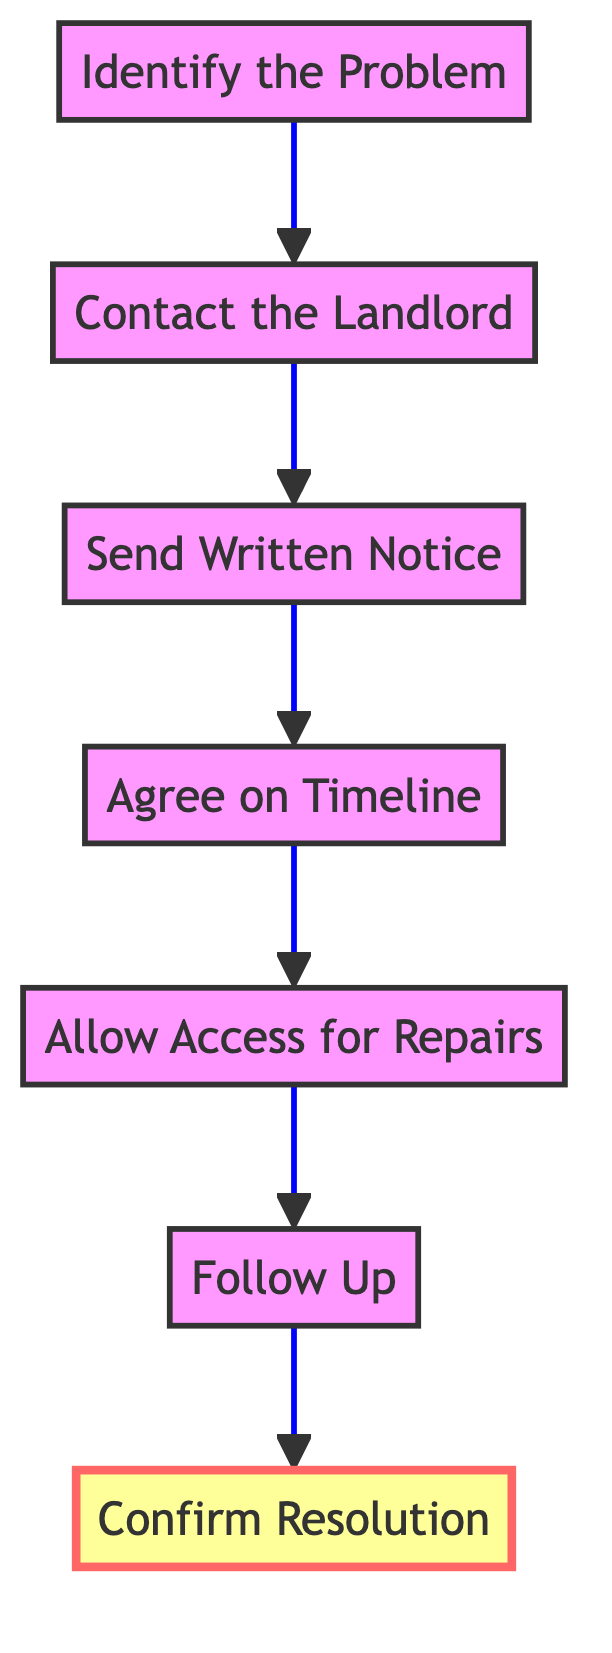What is the first step in addressing a maintenance issue? The first step in the diagram is identified as "Identify the Problem." It is the starting point of the flow and feeds into the subsequent steps involved in addressing the maintenance issue.
Answer: Identify the Problem How many total steps are there in the diagram? By counting each distinct step in the flowchart, we find there are seven individual steps. Each step represents a specific action to be taken to address the maintenance issue.
Answer: Seven What should you do after sending written notice? According to the flowchart, after sending written notice ("Send Written Notice"), the next step is to "Agree on Timeline," which indicates the requirement to discuss and finalize when repairs will occur.
Answer: Agree on Timeline What concludes the flow of actions in the diagram? The conclusion of the flow of actions is represented by the step "Confirm Resolution," which indicates the final action to ensure the maintenance issue has been resolved satisfactorily after all prior steps have been completed.
Answer: Confirm Resolution What action is required if the maintenance issue is not resolved? If the maintenance issue is not resolved, the flowchart directs to "Follow Up" with the landlord or property manager, indicating that additional communication is necessary to ensure the issue is addressed.
Answer: Follow Up Which two steps are focused on communication with the landlord? The two steps that focus on communication are "Contact the Landlord" and "Send Written Notice." These steps emphasize the importance of notifying the landlord about the maintenance issue both verbally and in writing.
Answer: Contact the Landlord; Send Written Notice Is allowing access for repairs a step that comes before or after agreeing on a timeline? In the flowchart, "Allow Access for Repairs" comes after "Agree on Timeline." This order signifies that first, a timeline for repairs should be established before granting access for those repairs to take place.
Answer: After What happens immediately after confirming resolution? The flowchart indicates that "Confirm Resolution" is the final step; therefore, there is no action that occurs immediately after it, marking the completion of the process for addressing the maintenance issue.
Answer: None 